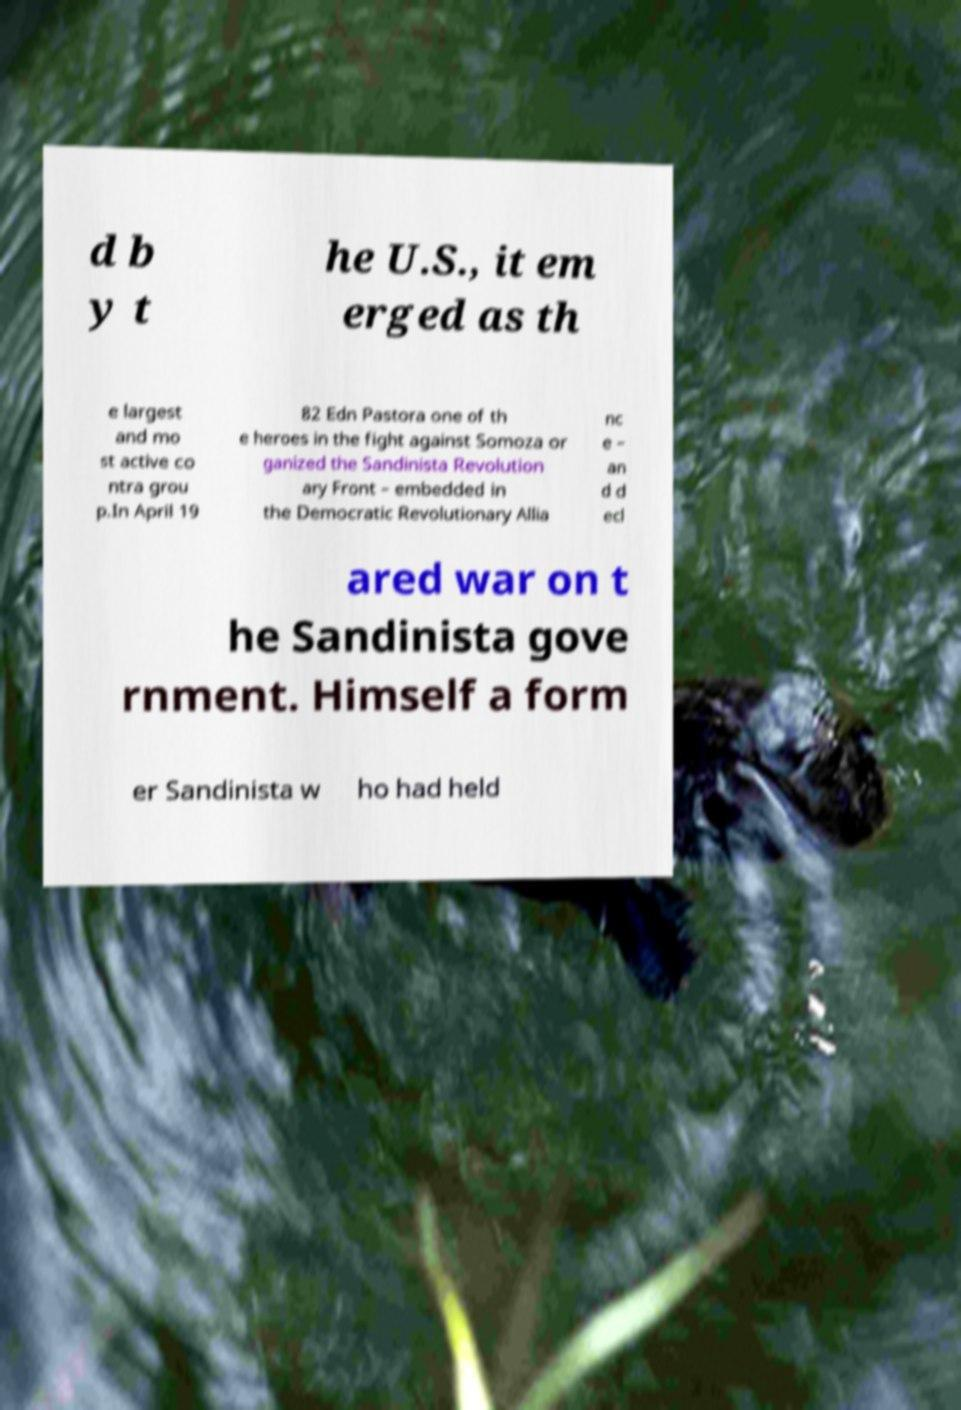Please identify and transcribe the text found in this image. d b y t he U.S., it em erged as th e largest and mo st active co ntra grou p.In April 19 82 Edn Pastora one of th e heroes in the fight against Somoza or ganized the Sandinista Revolution ary Front – embedded in the Democratic Revolutionary Allia nc e – an d d ecl ared war on t he Sandinista gove rnment. Himself a form er Sandinista w ho had held 